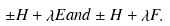Convert formula to latex. <formula><loc_0><loc_0><loc_500><loc_500>\pm H + \lambda E a n d \pm H + \lambda F .</formula> 